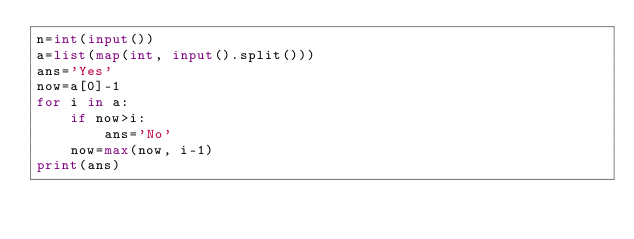Convert code to text. <code><loc_0><loc_0><loc_500><loc_500><_Python_>n=int(input())
a=list(map(int, input().split()))
ans='Yes'
now=a[0]-1
for i in a: 
    if now>i:
        ans='No'
    now=max(now, i-1)
print(ans)</code> 